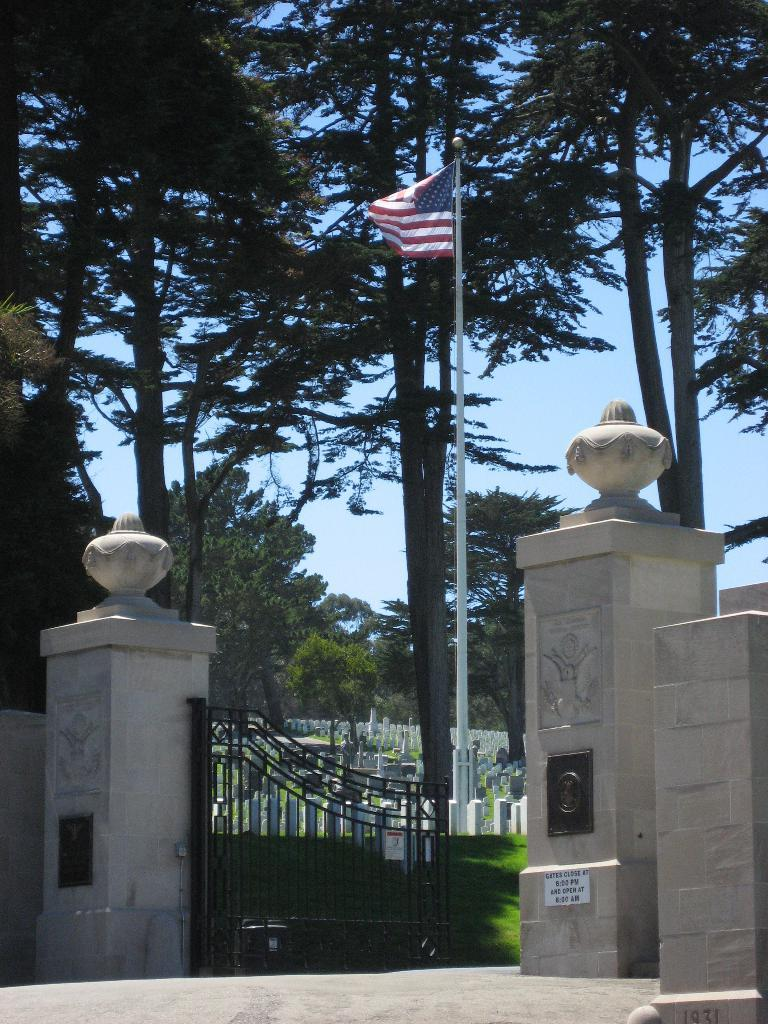What type of architectural elements can be seen in the image? There are pillars and a wall visible in the image. What type of entrance is present in the image? There is a gate in the image. What is attached to the gate in the image? There is a flag attached to the gate in the image. What can be found on the ground in the image? There are objects on the surface of the grass in the image. What type of vegetation is visible in the image? Trees are visible in the image. What part of the natural environment is visible in the image? The sky is visible in the image. How many people are gathered under the umbrella in the image? There is no umbrella present in the image. What is the weight of the crowd in the image? There is no crowd present in the image, so it is not possible to determine the weight. 